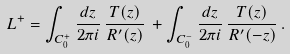Convert formula to latex. <formula><loc_0><loc_0><loc_500><loc_500>L ^ { + } = \int _ { C _ { 0 } ^ { + } } \frac { d z } { 2 \pi i } \, \frac { T ( z ) } { R ^ { \prime } ( z ) } \, + \int _ { C _ { 0 } ^ { - } } \frac { d z } { 2 \pi i } \, \frac { T ( z ) } { R ^ { \prime } ( - z ) } \, .</formula> 